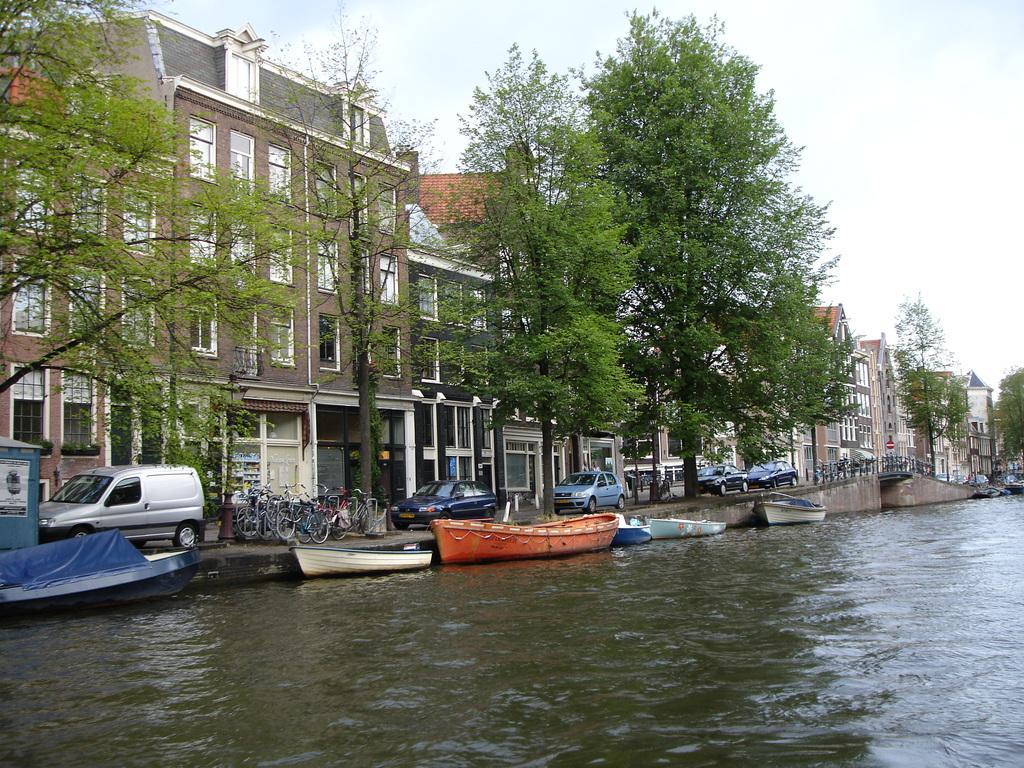In one or two sentences, can you explain what this image depicts? In this image I can see few boats on the water, background I can see few vehicles, trees in green color, buildings in brown, gray and cream color and the sky is in white color. 